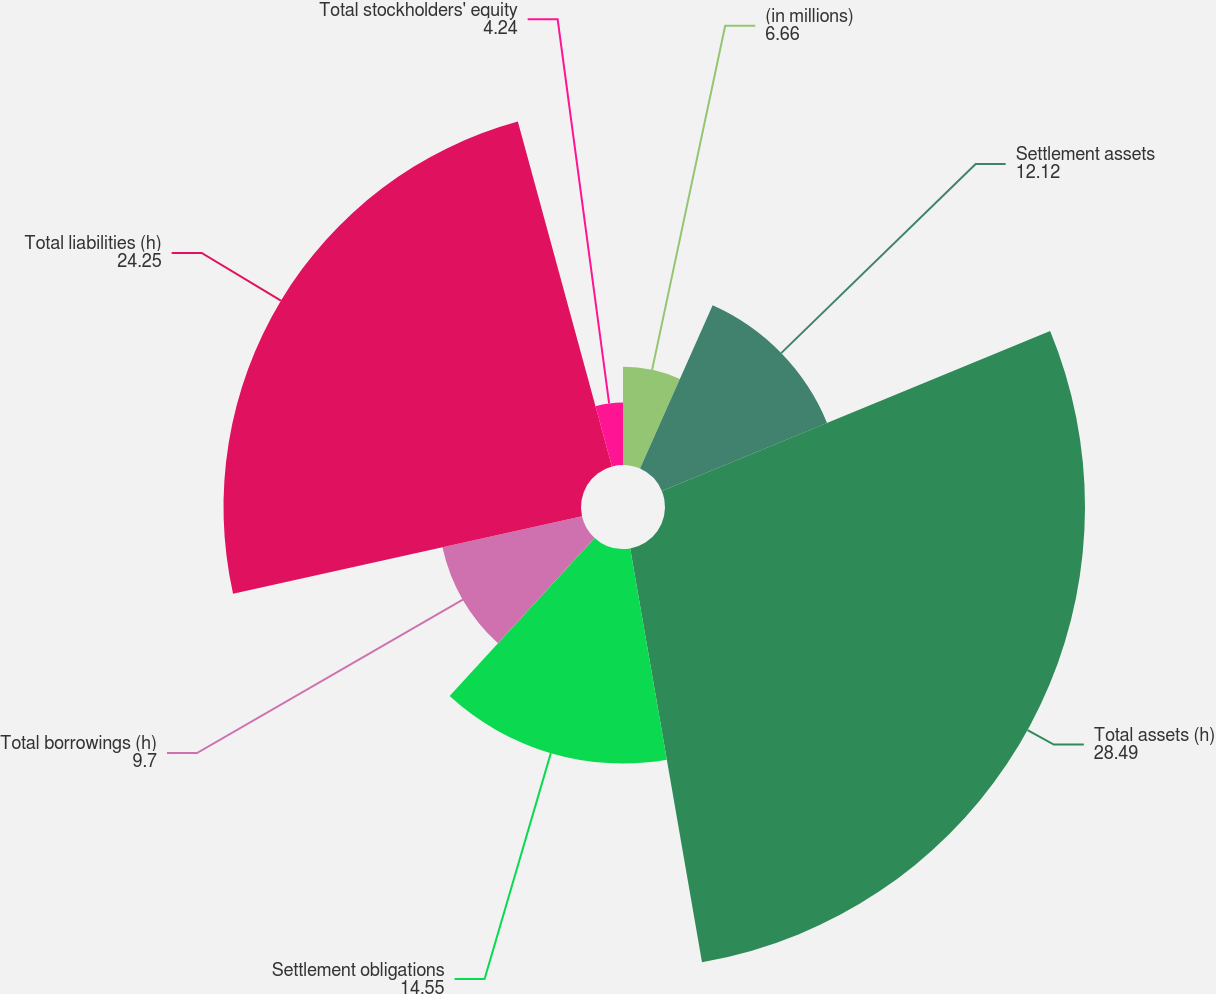Convert chart to OTSL. <chart><loc_0><loc_0><loc_500><loc_500><pie_chart><fcel>(in millions)<fcel>Settlement assets<fcel>Total assets (h)<fcel>Settlement obligations<fcel>Total borrowings (h)<fcel>Total liabilities (h)<fcel>Total stockholders' equity<nl><fcel>6.66%<fcel>12.12%<fcel>28.49%<fcel>14.55%<fcel>9.7%<fcel>24.25%<fcel>4.24%<nl></chart> 